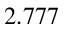<formula> <loc_0><loc_0><loc_500><loc_500>2 . 7 7 7</formula> 